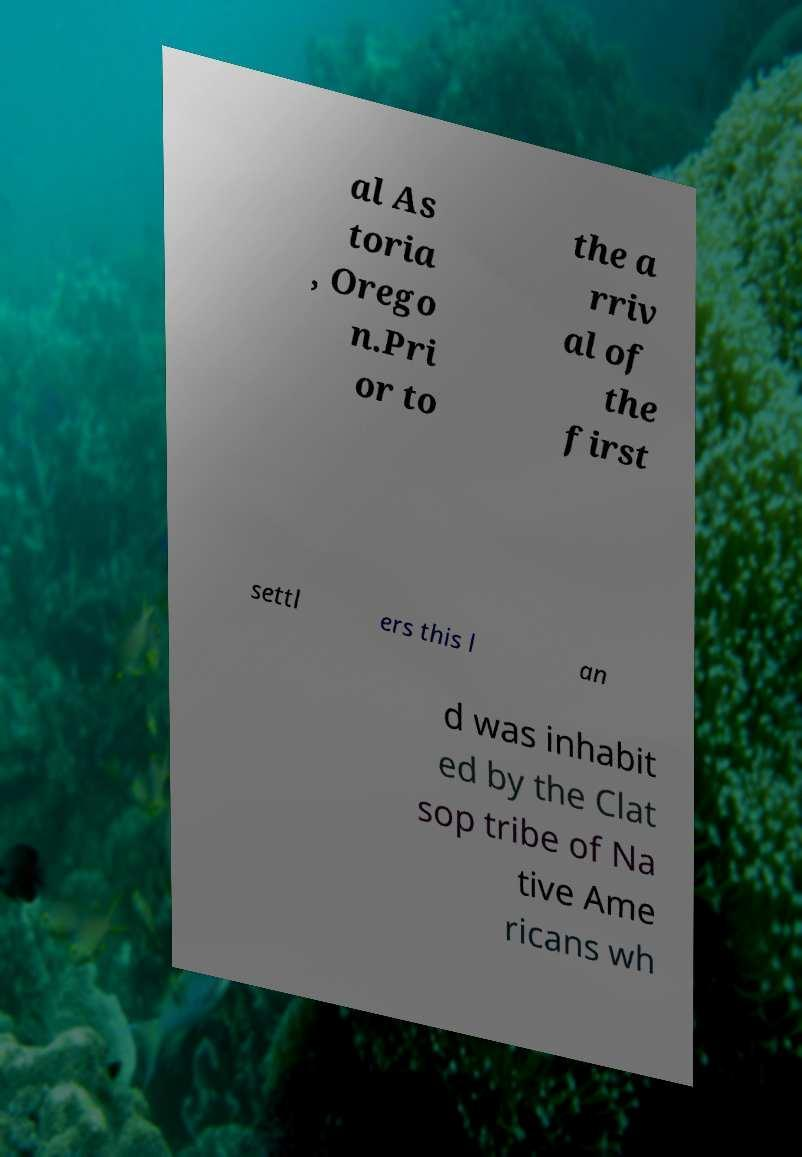Please identify and transcribe the text found in this image. al As toria , Orego n.Pri or to the a rriv al of the first settl ers this l an d was inhabit ed by the Clat sop tribe of Na tive Ame ricans wh 